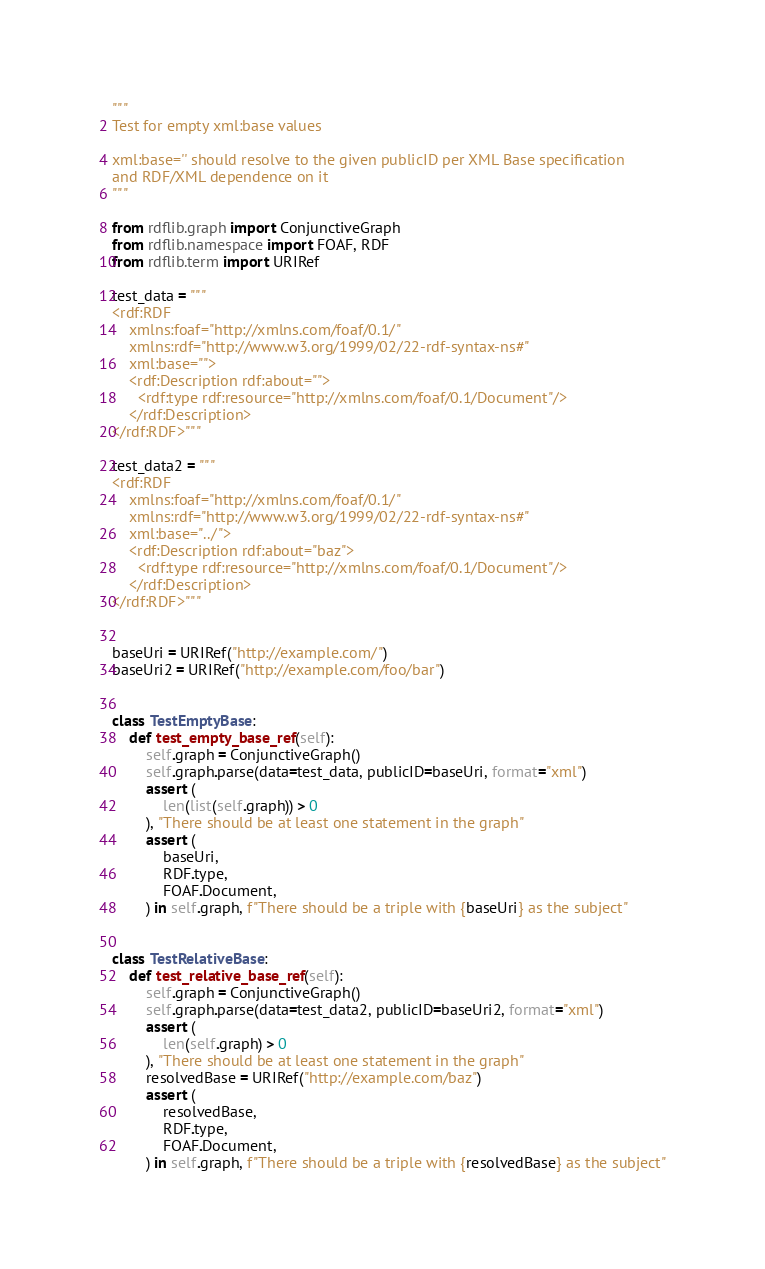Convert code to text. <code><loc_0><loc_0><loc_500><loc_500><_Python_>"""
Test for empty xml:base values

xml:base='' should resolve to the given publicID per XML Base specification
and RDF/XML dependence on it
"""

from rdflib.graph import ConjunctiveGraph
from rdflib.namespace import FOAF, RDF
from rdflib.term import URIRef

test_data = """
<rdf:RDF
    xmlns:foaf="http://xmlns.com/foaf/0.1/"
    xmlns:rdf="http://www.w3.org/1999/02/22-rdf-syntax-ns#"
    xml:base="">
    <rdf:Description rdf:about="">
      <rdf:type rdf:resource="http://xmlns.com/foaf/0.1/Document"/>
    </rdf:Description>
</rdf:RDF>"""

test_data2 = """
<rdf:RDF
    xmlns:foaf="http://xmlns.com/foaf/0.1/"
    xmlns:rdf="http://www.w3.org/1999/02/22-rdf-syntax-ns#"
    xml:base="../">
    <rdf:Description rdf:about="baz">
      <rdf:type rdf:resource="http://xmlns.com/foaf/0.1/Document"/>
    </rdf:Description>
</rdf:RDF>"""


baseUri = URIRef("http://example.com/")
baseUri2 = URIRef("http://example.com/foo/bar")


class TestEmptyBase:
    def test_empty_base_ref(self):
        self.graph = ConjunctiveGraph()
        self.graph.parse(data=test_data, publicID=baseUri, format="xml")
        assert (
            len(list(self.graph)) > 0
        ), "There should be at least one statement in the graph"
        assert (
            baseUri,
            RDF.type,
            FOAF.Document,
        ) in self.graph, f"There should be a triple with {baseUri} as the subject"


class TestRelativeBase:
    def test_relative_base_ref(self):
        self.graph = ConjunctiveGraph()
        self.graph.parse(data=test_data2, publicID=baseUri2, format="xml")
        assert (
            len(self.graph) > 0
        ), "There should be at least one statement in the graph"
        resolvedBase = URIRef("http://example.com/baz")
        assert (
            resolvedBase,
            RDF.type,
            FOAF.Document,
        ) in self.graph, f"There should be a triple with {resolvedBase} as the subject"
</code> 